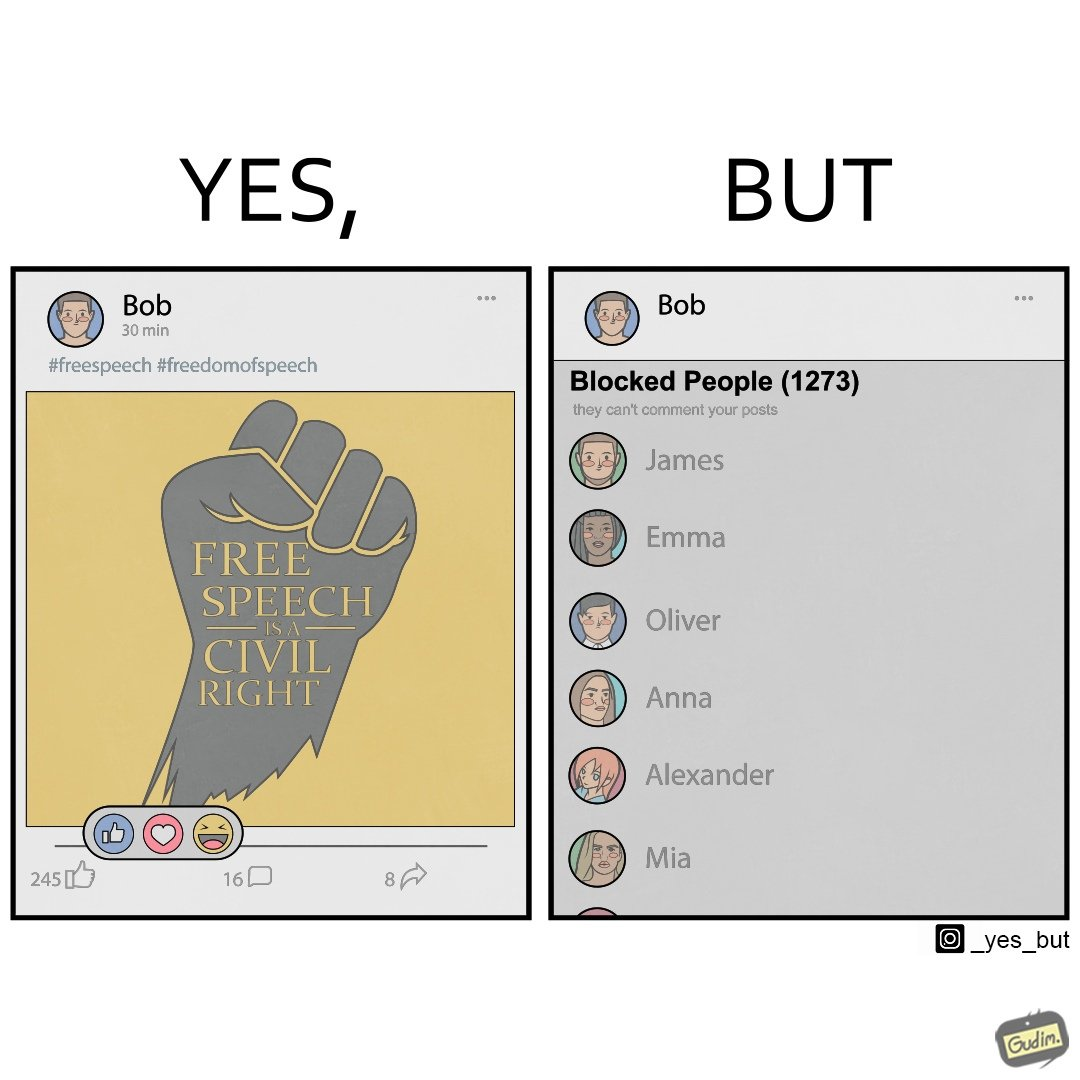Is there satirical content in this image? Yes, this image is satirical. 